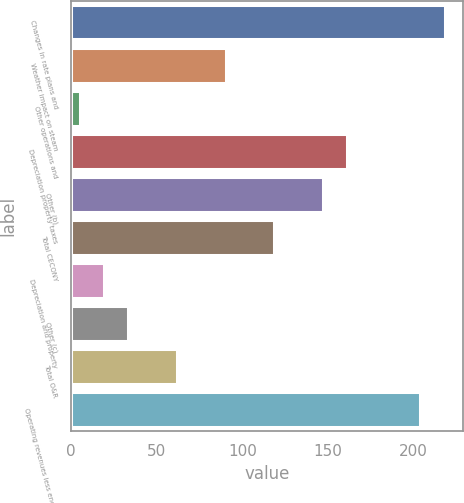Convert chart to OTSL. <chart><loc_0><loc_0><loc_500><loc_500><bar_chart><fcel>Changes in rate plans and<fcel>Weather impact on steam<fcel>Other operations and<fcel>Depreciation property taxes<fcel>Other (b)<fcel>Total CECONY<fcel>Depreciation and property<fcel>Other (c)<fcel>Total O&R<fcel>Operating revenues less energy<nl><fcel>218<fcel>90.2<fcel>5<fcel>161.2<fcel>147<fcel>118.6<fcel>19.2<fcel>33.4<fcel>61.8<fcel>203.8<nl></chart> 